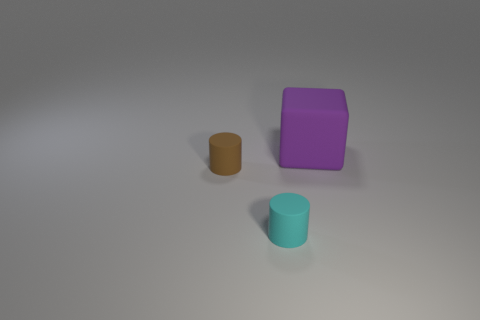Subtract 1 blocks. How many blocks are left? 0 Add 2 large rubber objects. How many objects exist? 5 Add 2 brown rubber cylinders. How many brown rubber cylinders are left? 3 Add 3 brown cylinders. How many brown cylinders exist? 4 Subtract all cyan cylinders. How many cylinders are left? 1 Subtract 0 red cylinders. How many objects are left? 3 Subtract all cylinders. How many objects are left? 1 Subtract all green cylinders. Subtract all brown balls. How many cylinders are left? 2 Subtract all purple balls. How many brown cylinders are left? 1 Subtract all green rubber things. Subtract all cyan cylinders. How many objects are left? 2 